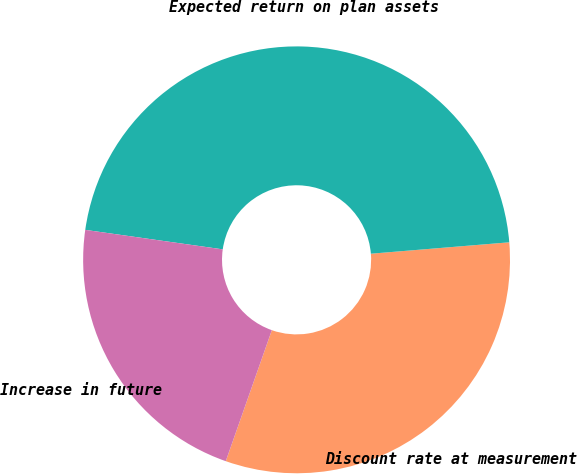Convert chart to OTSL. <chart><loc_0><loc_0><loc_500><loc_500><pie_chart><fcel>Discount rate at measurement<fcel>Expected return on plan assets<fcel>Increase in future<nl><fcel>31.69%<fcel>46.45%<fcel>21.86%<nl></chart> 